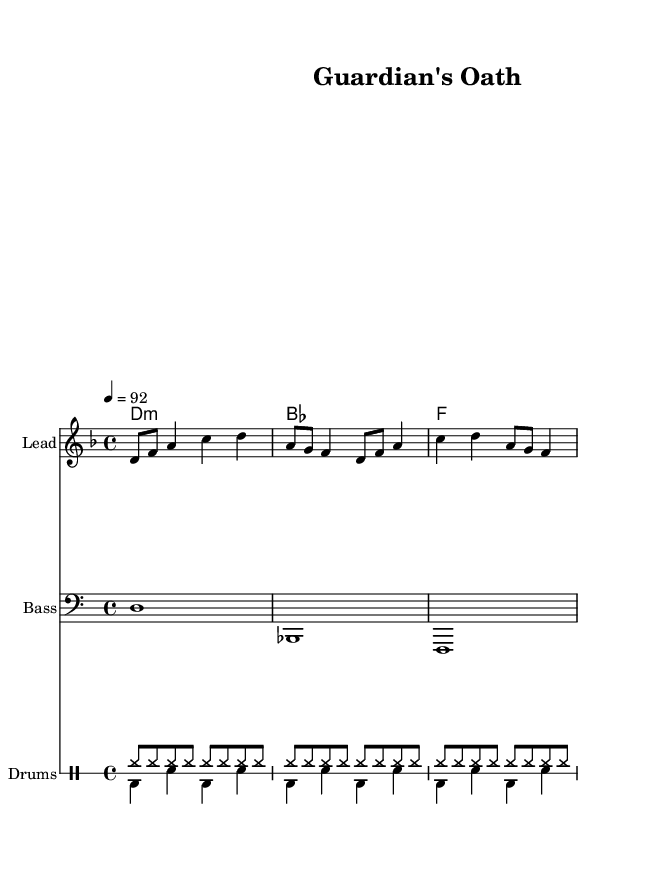What is the key signature of this music? The key signature is D minor, which has one flat. You can identify the key signature at the beginning of the music where the sharps/flats are indicated.
Answer: D minor What is the time signature of this music? The time signature is 4/4, which means there are four beats per measure. The time signature is located near the beginning of the sheet music, indicating how the beats are organized.
Answer: 4/4 What is the tempo marking of this music? The tempo marking is quarter note equals 92. This is represented by the notation at the start of the score, indicating how fast the piece should be played.
Answer: 92 How many measures are in the melody? There are eight measures in the melody. By counting each set of notes and rests separated by bar lines, we can reach the total.
Answer: 8 What is the primary theme addressed in the lyrics? The primary theme is protection and loyalty. By analyzing the lyrics, the focus is on being by someone's side and safeguarding them, which encapsulates brotherhood.
Answer: Protection and loyalty What type of instruments are used in the music? The instruments are Lead, Bass, and Drums. By looking at the different staves labeled at the beginning of the sections, we can ascertain the types of instruments utilized.
Answer: Lead, Bass, Drums What rhythmic pattern is used for the drums? The rhythmic pattern consists of hi-hat on eighth notes and bass drum/snare on quarter notes. This can be deduced from the specific notations in the drummode section of the score.
Answer: Hi-hat and bass/snare 